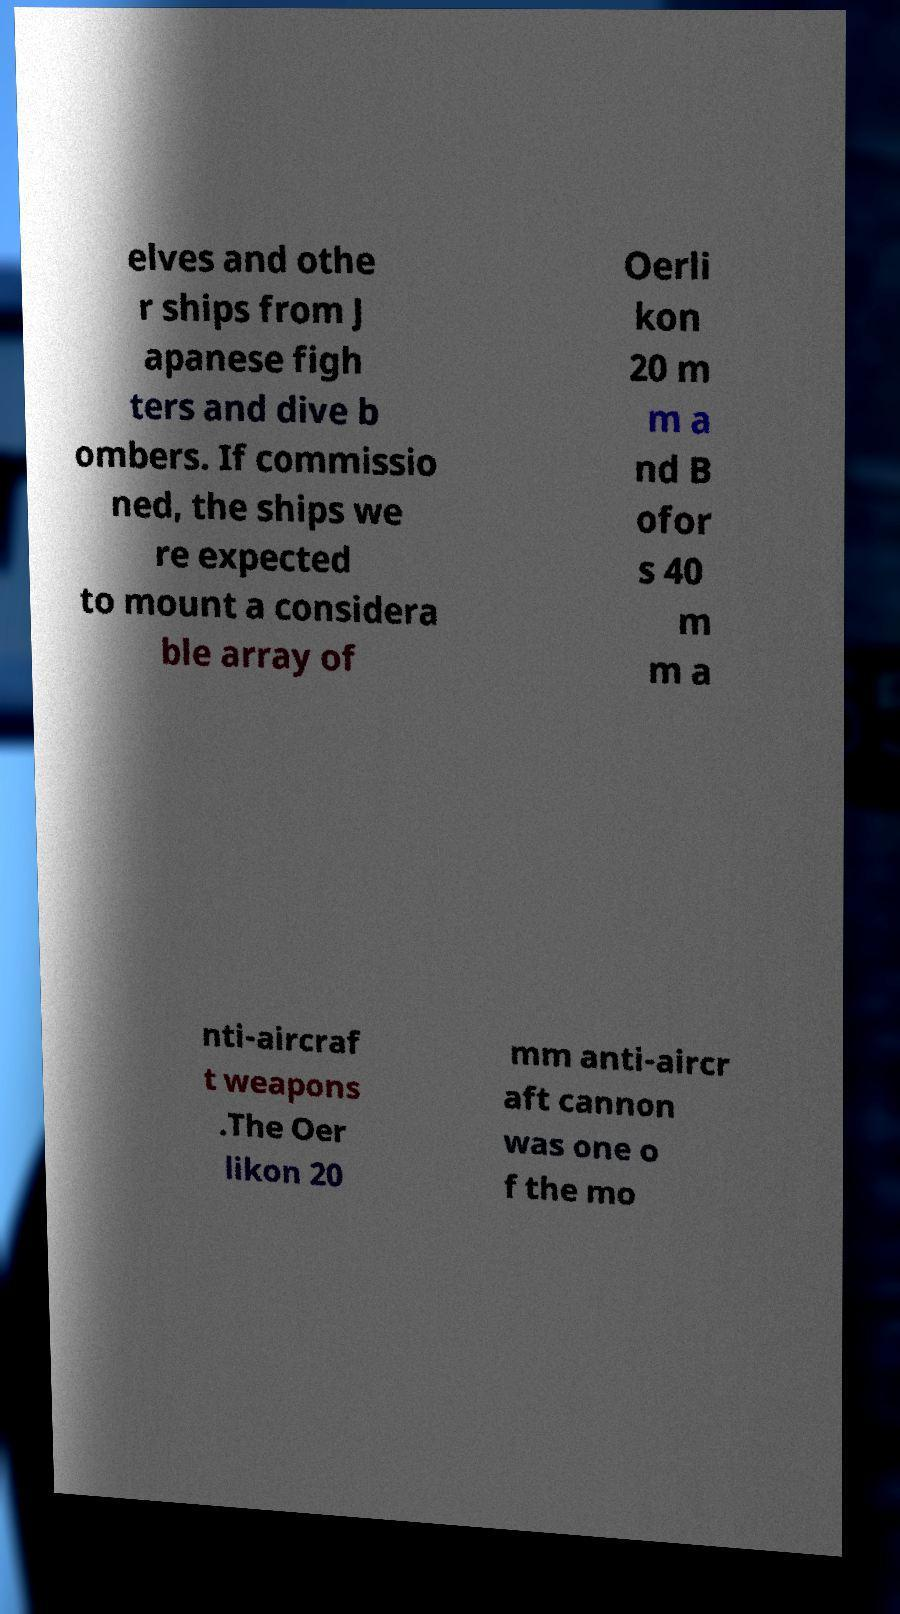Please identify and transcribe the text found in this image. elves and othe r ships from J apanese figh ters and dive b ombers. If commissio ned, the ships we re expected to mount a considera ble array of Oerli kon 20 m m a nd B ofor s 40 m m a nti-aircraf t weapons .The Oer likon 20 mm anti-aircr aft cannon was one o f the mo 